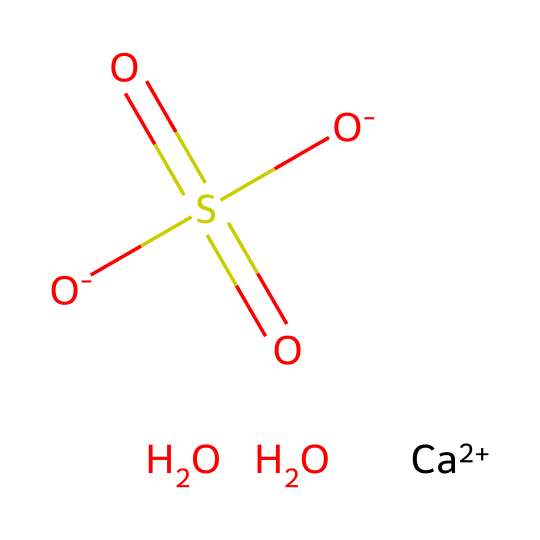How many oxygen atoms are present in gypsum? The chemical structure provided includes four oxygen atoms represented by the four O symbols in the SMILES notation.
Answer: four What is the oxidation state of calcium in gypsum? In the chemical structure, calcium is shown as [Ca+2], indicating that it has a +2 oxidation state.
Answer: +2 What type of bond connects calcium to the sulfate group in gypsum? The calcium ion [Ca+2] forms ionic bonds with the sulfate ion S(=O)(=O)[O-]. The interaction between the positively charged calcium ion and the negatively charged sulfate ion indicates ionic bonding.
Answer: ionic Which functional group is characteristic of gypsum? The presence of the sulfate group S(=O)(=O)[O-] indicates it contains the sulfate functional group, which is characteristic of gypsum.
Answer: sulfate How many sulfur atoms are in gypsum? The structure shows one sulfur atom represented by the S symbol in the sulfate group.
Answer: one What is the overall charge of the sulfate ion in gypsum? The sulfate ion S(=O)(=O)[O-] has a total charge of -2 due to the two negatively charged oxygen atoms.
Answer: -2 What kind of mineral is gypsum classified as? Gypsum is classified as an evaporite mineral since it forms from the evaporation of water, leading to the crystallization of minerals such as calcium sulfate.
Answer: evaporite 